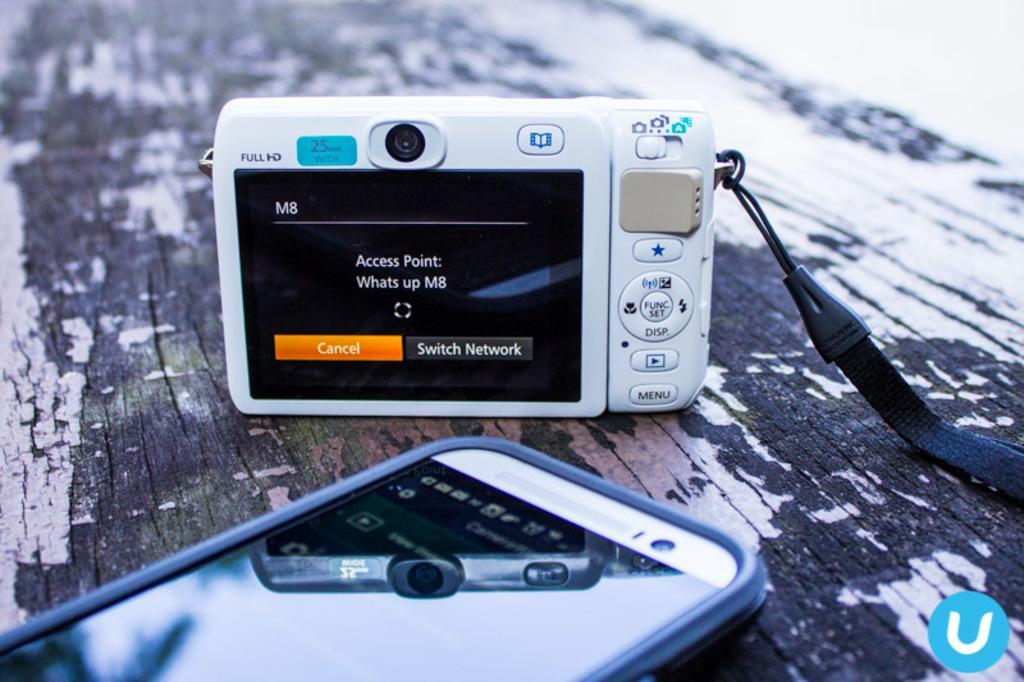In one or two sentences, can you explain what this image depicts? In this image, we can see a camera and mobile is placed on the wooden surface. Top of the image, we can see a blur view. Right side bottom corner, there is a logo. Here we can see some text, buttons and icons. 